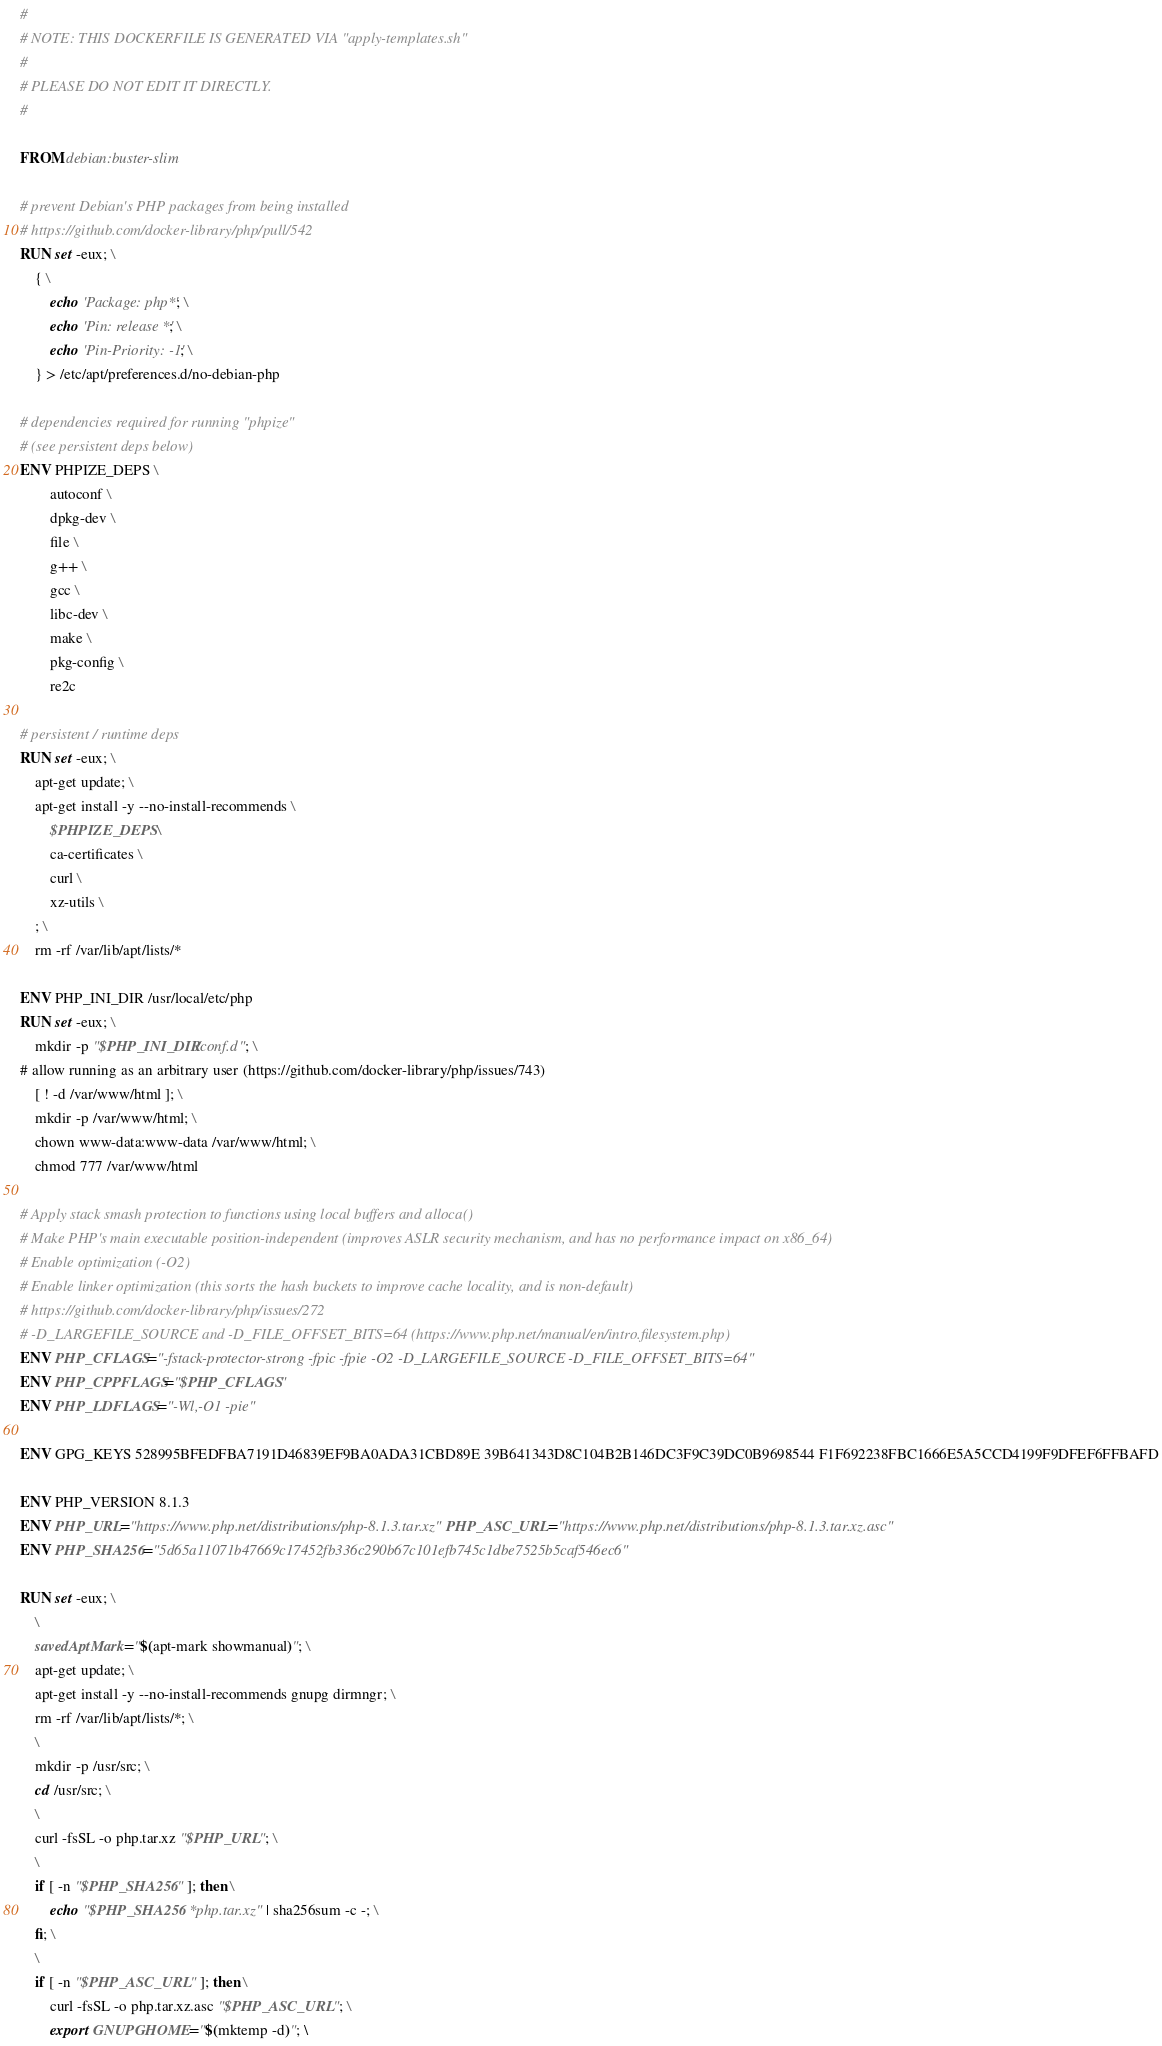Convert code to text. <code><loc_0><loc_0><loc_500><loc_500><_Dockerfile_>#
# NOTE: THIS DOCKERFILE IS GENERATED VIA "apply-templates.sh"
#
# PLEASE DO NOT EDIT IT DIRECTLY.
#

FROM debian:buster-slim

# prevent Debian's PHP packages from being installed
# https://github.com/docker-library/php/pull/542
RUN set -eux; \
	{ \
		echo 'Package: php*'; \
		echo 'Pin: release *'; \
		echo 'Pin-Priority: -1'; \
	} > /etc/apt/preferences.d/no-debian-php

# dependencies required for running "phpize"
# (see persistent deps below)
ENV PHPIZE_DEPS \
		autoconf \
		dpkg-dev \
		file \
		g++ \
		gcc \
		libc-dev \
		make \
		pkg-config \
		re2c

# persistent / runtime deps
RUN set -eux; \
	apt-get update; \
	apt-get install -y --no-install-recommends \
		$PHPIZE_DEPS \
		ca-certificates \
		curl \
		xz-utils \
	; \
	rm -rf /var/lib/apt/lists/*

ENV PHP_INI_DIR /usr/local/etc/php
RUN set -eux; \
	mkdir -p "$PHP_INI_DIR/conf.d"; \
# allow running as an arbitrary user (https://github.com/docker-library/php/issues/743)
	[ ! -d /var/www/html ]; \
	mkdir -p /var/www/html; \
	chown www-data:www-data /var/www/html; \
	chmod 777 /var/www/html

# Apply stack smash protection to functions using local buffers and alloca()
# Make PHP's main executable position-independent (improves ASLR security mechanism, and has no performance impact on x86_64)
# Enable optimization (-O2)
# Enable linker optimization (this sorts the hash buckets to improve cache locality, and is non-default)
# https://github.com/docker-library/php/issues/272
# -D_LARGEFILE_SOURCE and -D_FILE_OFFSET_BITS=64 (https://www.php.net/manual/en/intro.filesystem.php)
ENV PHP_CFLAGS="-fstack-protector-strong -fpic -fpie -O2 -D_LARGEFILE_SOURCE -D_FILE_OFFSET_BITS=64"
ENV PHP_CPPFLAGS="$PHP_CFLAGS"
ENV PHP_LDFLAGS="-Wl,-O1 -pie"

ENV GPG_KEYS 528995BFEDFBA7191D46839EF9BA0ADA31CBD89E 39B641343D8C104B2B146DC3F9C39DC0B9698544 F1F692238FBC1666E5A5CCD4199F9DFEF6FFBAFD

ENV PHP_VERSION 8.1.3
ENV PHP_URL="https://www.php.net/distributions/php-8.1.3.tar.xz" PHP_ASC_URL="https://www.php.net/distributions/php-8.1.3.tar.xz.asc"
ENV PHP_SHA256="5d65a11071b47669c17452fb336c290b67c101efb745c1dbe7525b5caf546ec6"

RUN set -eux; \
	\
	savedAptMark="$(apt-mark showmanual)"; \
	apt-get update; \
	apt-get install -y --no-install-recommends gnupg dirmngr; \
	rm -rf /var/lib/apt/lists/*; \
	\
	mkdir -p /usr/src; \
	cd /usr/src; \
	\
	curl -fsSL -o php.tar.xz "$PHP_URL"; \
	\
	if [ -n "$PHP_SHA256" ]; then \
		echo "$PHP_SHA256 *php.tar.xz" | sha256sum -c -; \
	fi; \
	\
	if [ -n "$PHP_ASC_URL" ]; then \
		curl -fsSL -o php.tar.xz.asc "$PHP_ASC_URL"; \
		export GNUPGHOME="$(mktemp -d)"; \</code> 